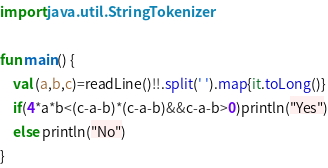Convert code to text. <code><loc_0><loc_0><loc_500><loc_500><_Kotlin_>import java.util.StringTokenizer

fun main() {
    val (a,b,c)=readLine()!!.split(' ').map{it.toLong()}
    if(4*a*b<(c-a-b)*(c-a-b)&&c-a-b>0)println("Yes")
    else println("No")
}</code> 